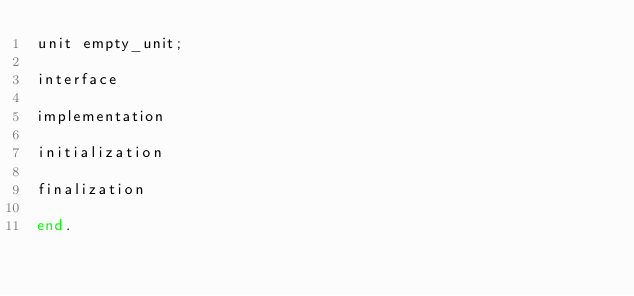Convert code to text. <code><loc_0><loc_0><loc_500><loc_500><_Pascal_>unit empty_unit;

interface

implementation

initialization

finalization
  
end.</code> 